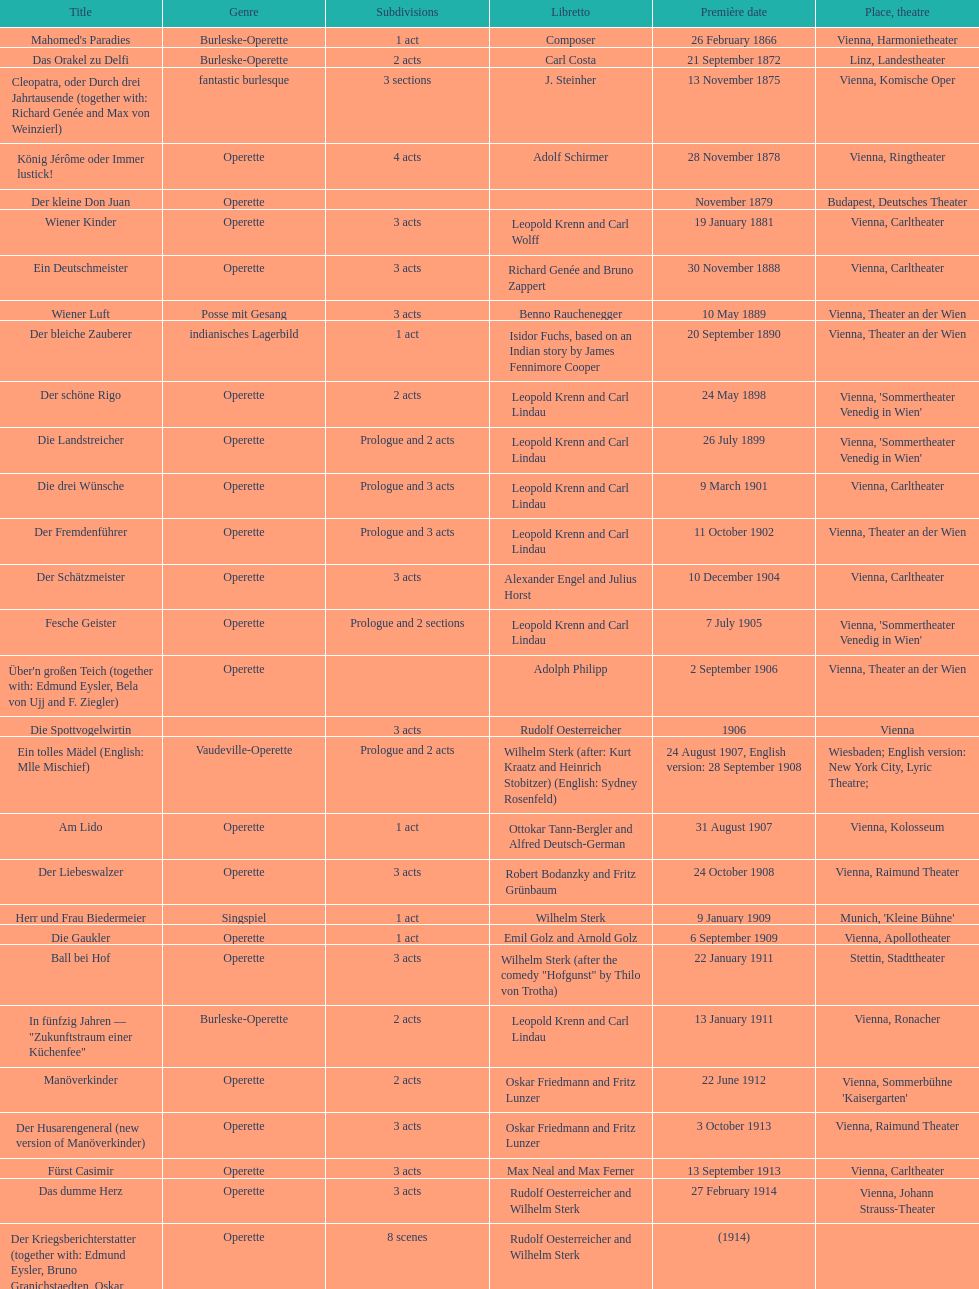Does der liebeswalzer or manöverkinder contain more acts? Der Liebeswalzer. 